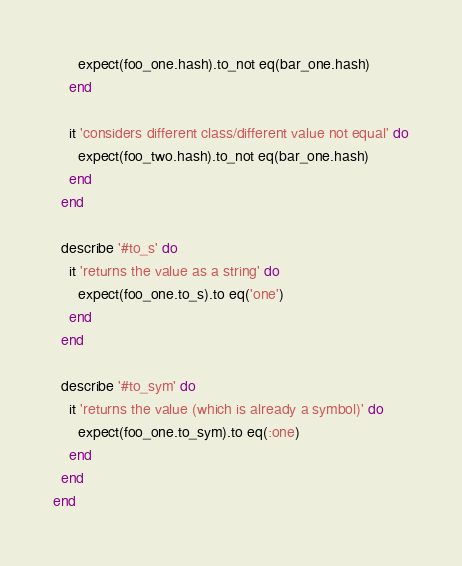<code> <loc_0><loc_0><loc_500><loc_500><_Ruby_>      expect(foo_one.hash).to_not eq(bar_one.hash)
    end

    it 'considers different class/different value not equal' do
      expect(foo_two.hash).to_not eq(bar_one.hash)
    end
  end

  describe '#to_s' do
    it 'returns the value as a string' do
      expect(foo_one.to_s).to eq('one')
    end
  end

  describe '#to_sym' do
    it 'returns the value (which is already a symbol)' do
      expect(foo_one.to_sym).to eq(:one)
    end
  end
end
</code> 